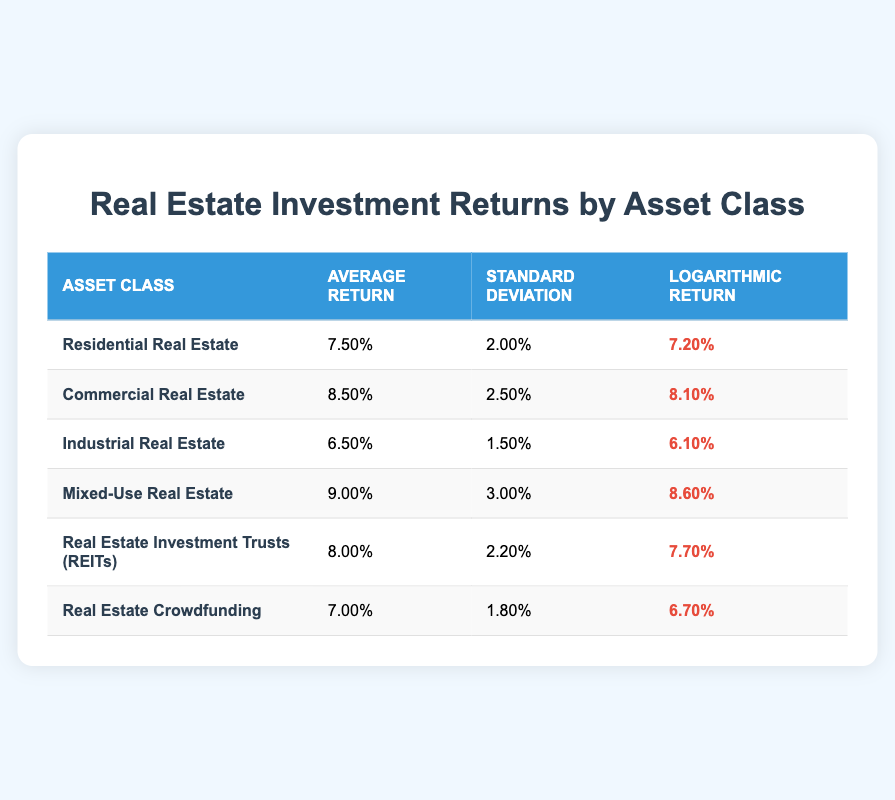What is the average return of Mixed-Use Real Estate? The table shows that the average return for Mixed-Use Real Estate is 9.00%.
Answer: 9.00% Which asset class has the highest standard deviation in returns? By comparing the standard deviations across all asset classes in the table, we see that Mixed-Use Real Estate has the highest standard deviation of 3.00%.
Answer: Mixed-Use Real Estate What is the difference in average return between Residential and Industrial Real Estate? The average return for Residential Real Estate is 7.50% and for Industrial Real Estate it is 6.50%. The difference is 7.50% - 6.50% = 1.00%.
Answer: 1.00% Is the logarithmic return of Real Estate Crowdfunding greater than that of Commercial Real Estate? The table shows the logarithmic return for Real Estate Crowdfunding is 6.70% and for Commercial Real Estate is 8.10%. Since 6.70% is less than 8.10%, the statement is false.
Answer: No What is the average of logarithmic returns for all asset classes listed in the table? The logarithmic returns in the table are 7.20%, 8.10%, 6.10%, 8.60%, 7.70%, and 6.70%. Summing these gives 44.50%, and dividing by 6 (the number of asset classes), the average is 7.42%.
Answer: 7.42% 